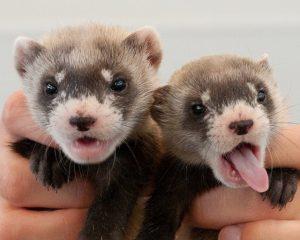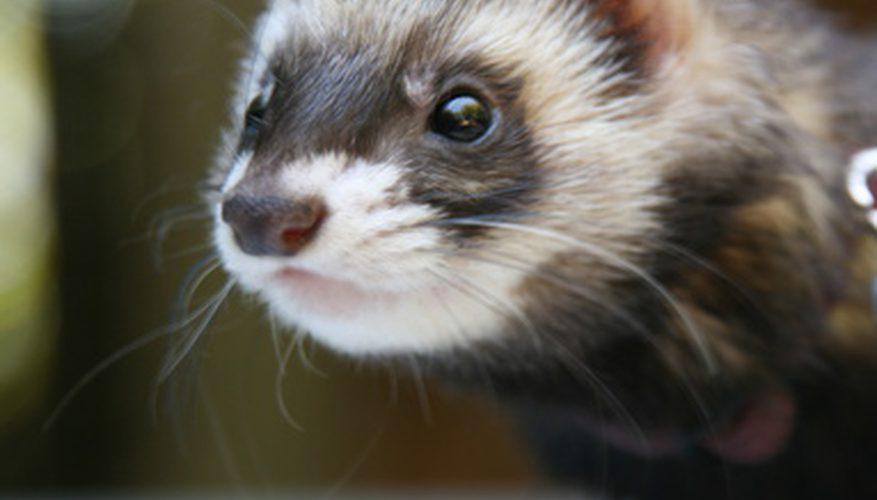The first image is the image on the left, the second image is the image on the right. For the images displayed, is the sentence "The right image contains a ferret sticking their head out of a dirt hole." factually correct? Answer yes or no. No. The first image is the image on the left, the second image is the image on the right. Considering the images on both sides, is "Each image shows a single ferret with its head emerging from a hole in the dirt." valid? Answer yes or no. No. 